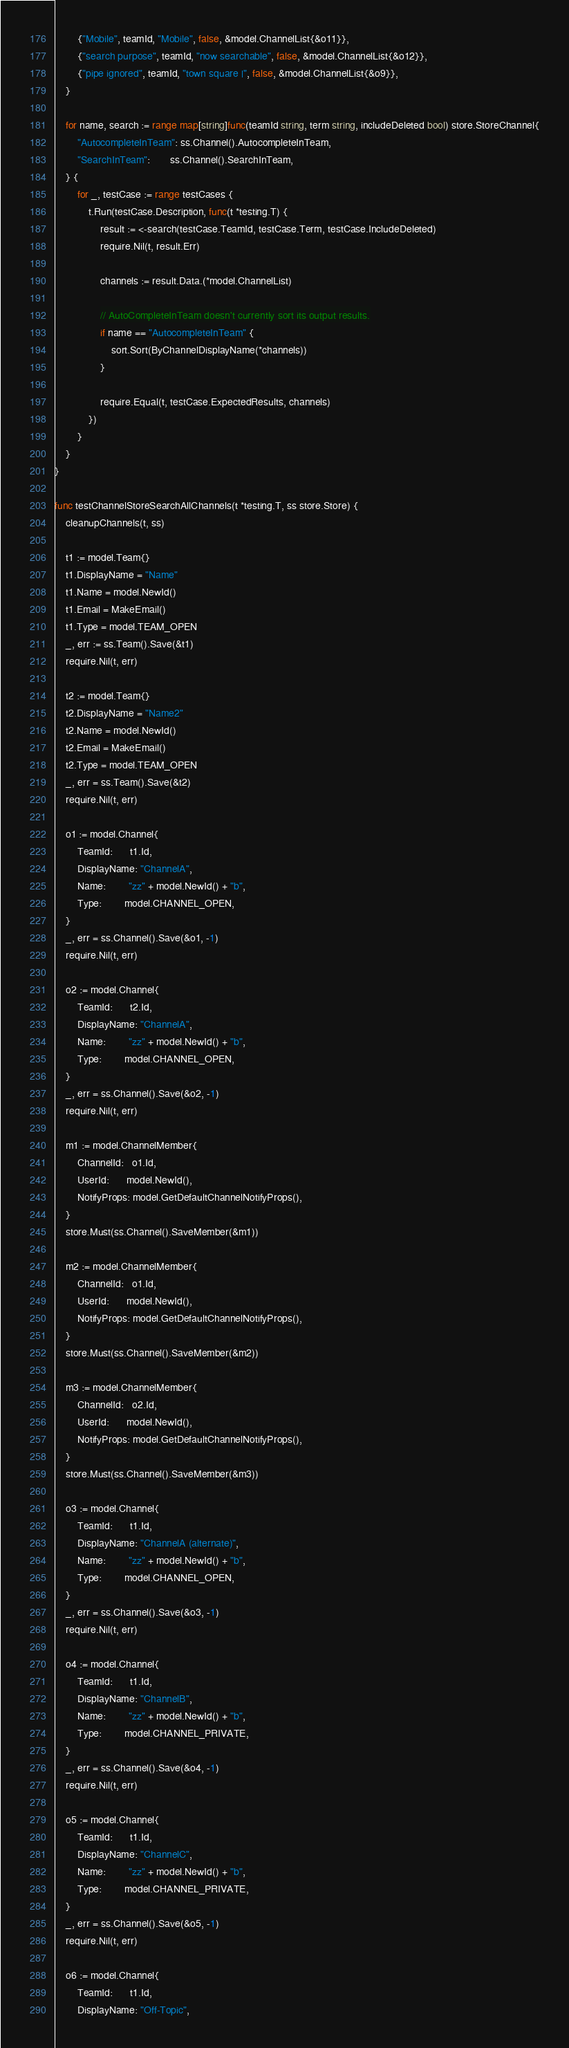<code> <loc_0><loc_0><loc_500><loc_500><_Go_>		{"Mobile", teamId, "Mobile", false, &model.ChannelList{&o11}},
		{"search purpose", teamId, "now searchable", false, &model.ChannelList{&o12}},
		{"pipe ignored", teamId, "town square |", false, &model.ChannelList{&o9}},
	}

	for name, search := range map[string]func(teamId string, term string, includeDeleted bool) store.StoreChannel{
		"AutocompleteInTeam": ss.Channel().AutocompleteInTeam,
		"SearchInTeam":       ss.Channel().SearchInTeam,
	} {
		for _, testCase := range testCases {
			t.Run(testCase.Description, func(t *testing.T) {
				result := <-search(testCase.TeamId, testCase.Term, testCase.IncludeDeleted)
				require.Nil(t, result.Err)

				channels := result.Data.(*model.ChannelList)

				// AutoCompleteInTeam doesn't currently sort its output results.
				if name == "AutocompleteInTeam" {
					sort.Sort(ByChannelDisplayName(*channels))
				}

				require.Equal(t, testCase.ExpectedResults, channels)
			})
		}
	}
}

func testChannelStoreSearchAllChannels(t *testing.T, ss store.Store) {
	cleanupChannels(t, ss)

	t1 := model.Team{}
	t1.DisplayName = "Name"
	t1.Name = model.NewId()
	t1.Email = MakeEmail()
	t1.Type = model.TEAM_OPEN
	_, err := ss.Team().Save(&t1)
	require.Nil(t, err)

	t2 := model.Team{}
	t2.DisplayName = "Name2"
	t2.Name = model.NewId()
	t2.Email = MakeEmail()
	t2.Type = model.TEAM_OPEN
	_, err = ss.Team().Save(&t2)
	require.Nil(t, err)

	o1 := model.Channel{
		TeamId:      t1.Id,
		DisplayName: "ChannelA",
		Name:        "zz" + model.NewId() + "b",
		Type:        model.CHANNEL_OPEN,
	}
	_, err = ss.Channel().Save(&o1, -1)
	require.Nil(t, err)

	o2 := model.Channel{
		TeamId:      t2.Id,
		DisplayName: "ChannelA",
		Name:        "zz" + model.NewId() + "b",
		Type:        model.CHANNEL_OPEN,
	}
	_, err = ss.Channel().Save(&o2, -1)
	require.Nil(t, err)

	m1 := model.ChannelMember{
		ChannelId:   o1.Id,
		UserId:      model.NewId(),
		NotifyProps: model.GetDefaultChannelNotifyProps(),
	}
	store.Must(ss.Channel().SaveMember(&m1))

	m2 := model.ChannelMember{
		ChannelId:   o1.Id,
		UserId:      model.NewId(),
		NotifyProps: model.GetDefaultChannelNotifyProps(),
	}
	store.Must(ss.Channel().SaveMember(&m2))

	m3 := model.ChannelMember{
		ChannelId:   o2.Id,
		UserId:      model.NewId(),
		NotifyProps: model.GetDefaultChannelNotifyProps(),
	}
	store.Must(ss.Channel().SaveMember(&m3))

	o3 := model.Channel{
		TeamId:      t1.Id,
		DisplayName: "ChannelA (alternate)",
		Name:        "zz" + model.NewId() + "b",
		Type:        model.CHANNEL_OPEN,
	}
	_, err = ss.Channel().Save(&o3, -1)
	require.Nil(t, err)

	o4 := model.Channel{
		TeamId:      t1.Id,
		DisplayName: "ChannelB",
		Name:        "zz" + model.NewId() + "b",
		Type:        model.CHANNEL_PRIVATE,
	}
	_, err = ss.Channel().Save(&o4, -1)
	require.Nil(t, err)

	o5 := model.Channel{
		TeamId:      t1.Id,
		DisplayName: "ChannelC",
		Name:        "zz" + model.NewId() + "b",
		Type:        model.CHANNEL_PRIVATE,
	}
	_, err = ss.Channel().Save(&o5, -1)
	require.Nil(t, err)

	o6 := model.Channel{
		TeamId:      t1.Id,
		DisplayName: "Off-Topic",</code> 